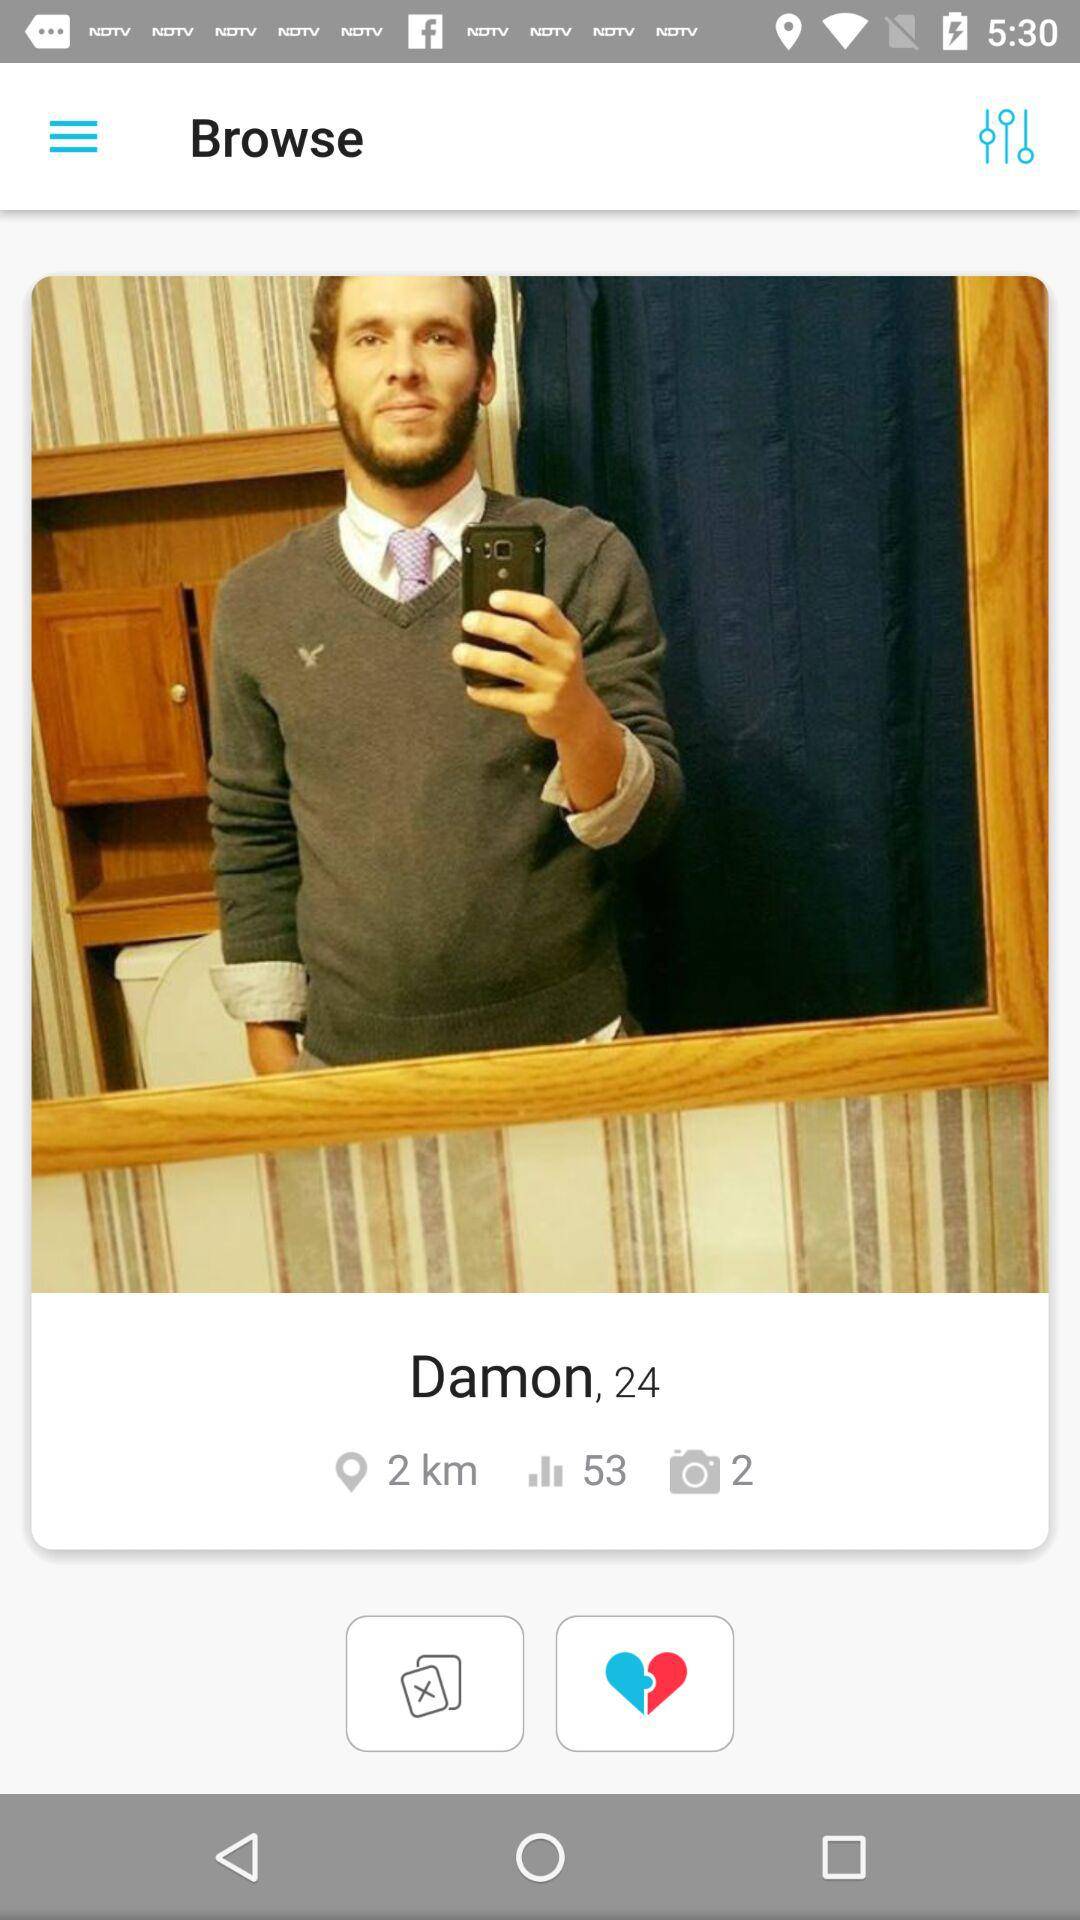What is the name of the user? The name of the user is Damon. 